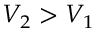Convert formula to latex. <formula><loc_0><loc_0><loc_500><loc_500>V _ { 2 } > V _ { 1 }</formula> 